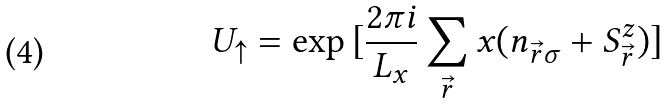Convert formula to latex. <formula><loc_0><loc_0><loc_500><loc_500>U _ { \uparrow } = \exp { [ \frac { 2 \pi i } { L _ { x } } \sum _ { \vec { r } } x ( n _ { \vec { r } \sigma } + S ^ { z } _ { \vec { r } } ) ] }</formula> 